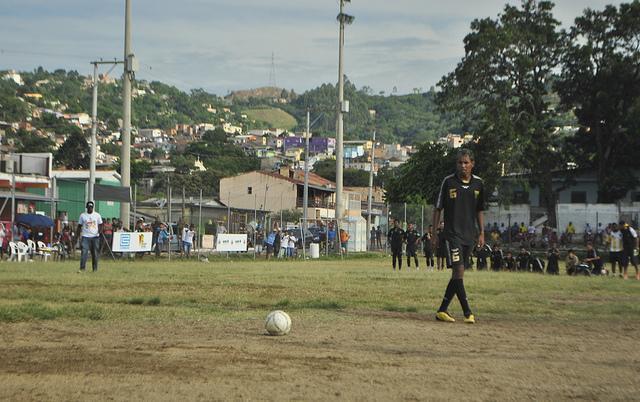What international tournament takes place every 4 years where this sport is played?
Pick the correct solution from the four options below to address the question.
Options: World championship, winner's cup, stanley cup, world cup. World cup. 